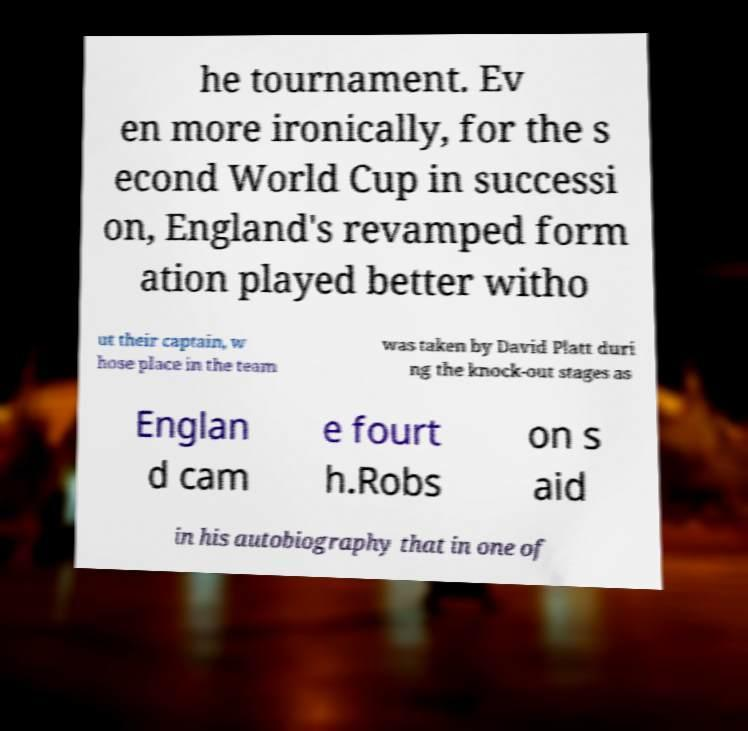Can you accurately transcribe the text from the provided image for me? he tournament. Ev en more ironically, for the s econd World Cup in successi on, England's revamped form ation played better witho ut their captain, w hose place in the team was taken by David Platt duri ng the knock-out stages as Englan d cam e fourt h.Robs on s aid in his autobiography that in one of 